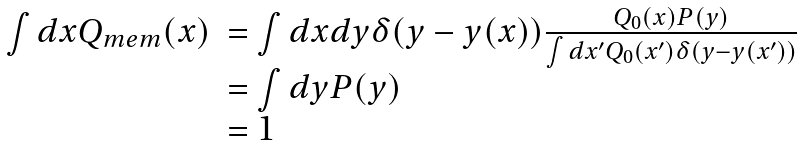Convert formula to latex. <formula><loc_0><loc_0><loc_500><loc_500>\begin{array} { r l } \int d x Q _ { m e m } ( x ) & = \int d x d y \delta ( y - y ( x ) ) \frac { Q _ { 0 } ( x ) P ( y ) } { \int d x ^ { \prime } Q _ { 0 } ( x ^ { \prime } ) \delta ( y - y ( x ^ { \prime } ) ) } \\ & = \int d y P ( y ) \\ & = 1 \end{array}</formula> 